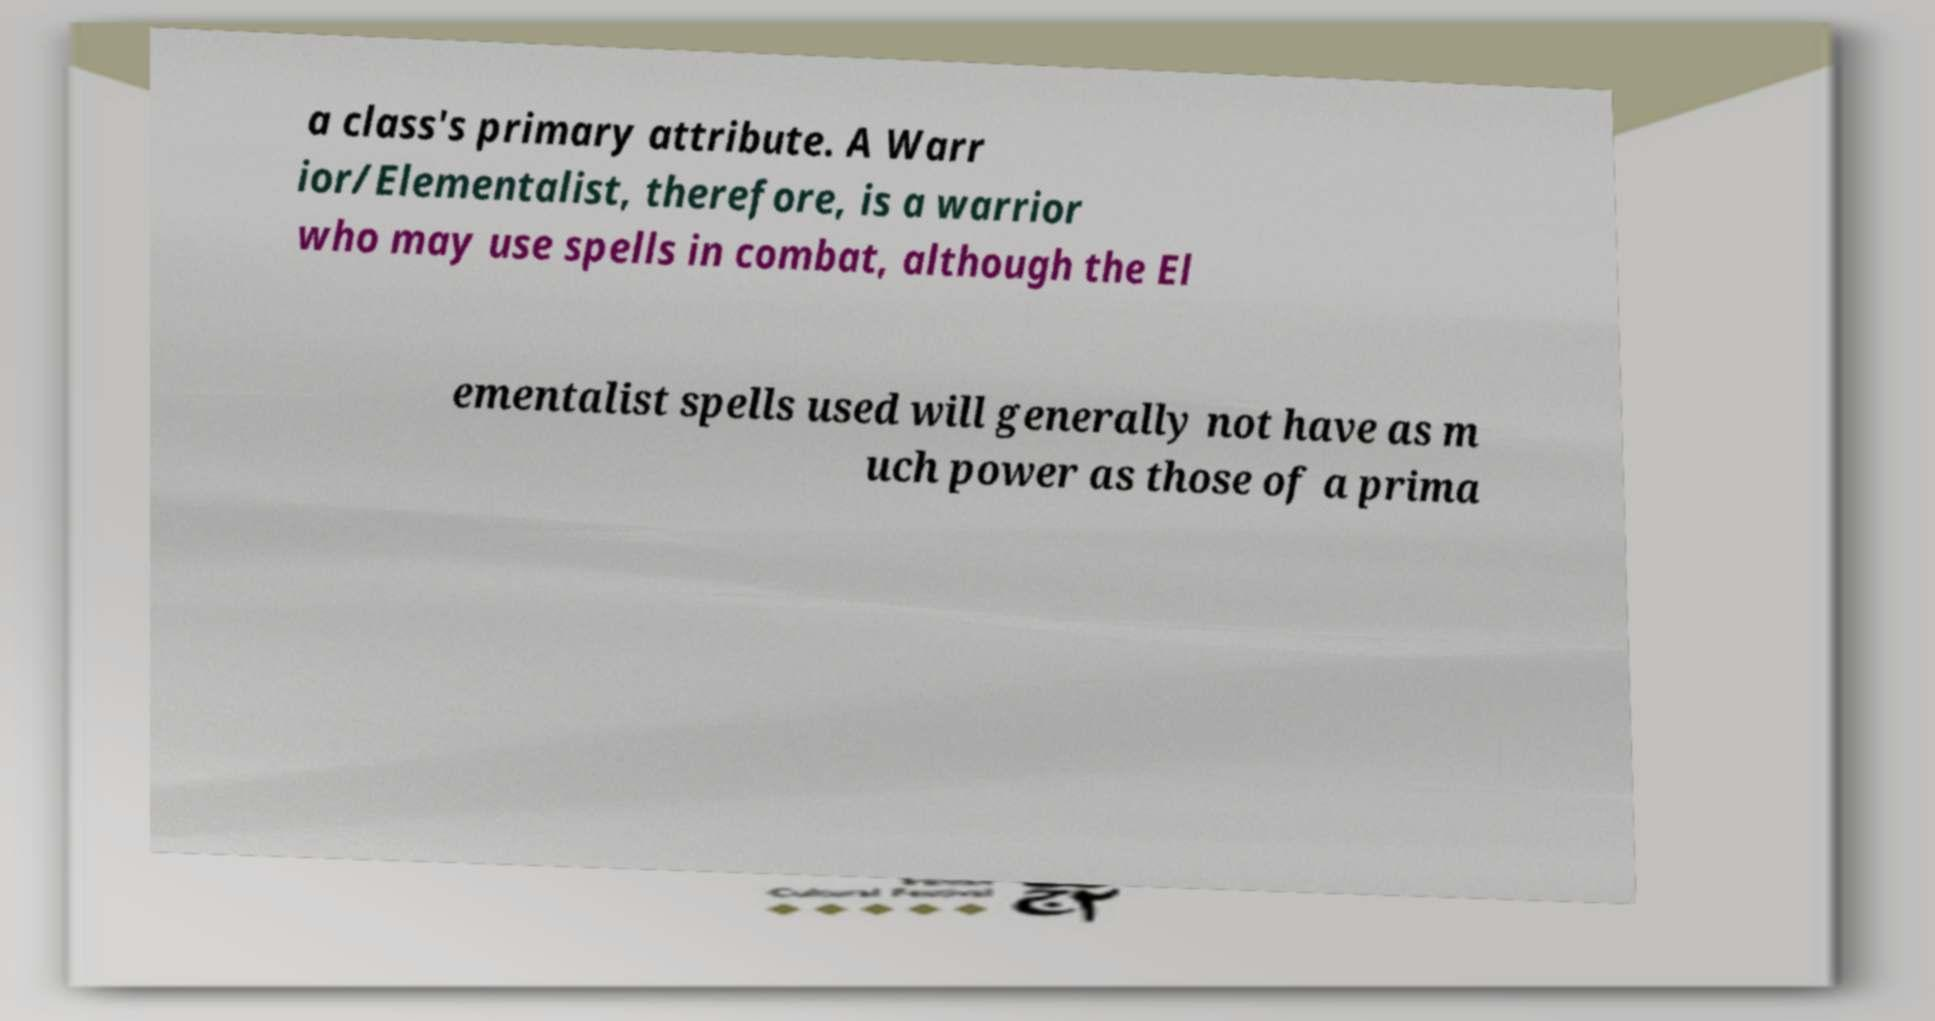Please identify and transcribe the text found in this image. a class's primary attribute. A Warr ior/Elementalist, therefore, is a warrior who may use spells in combat, although the El ementalist spells used will generally not have as m uch power as those of a prima 